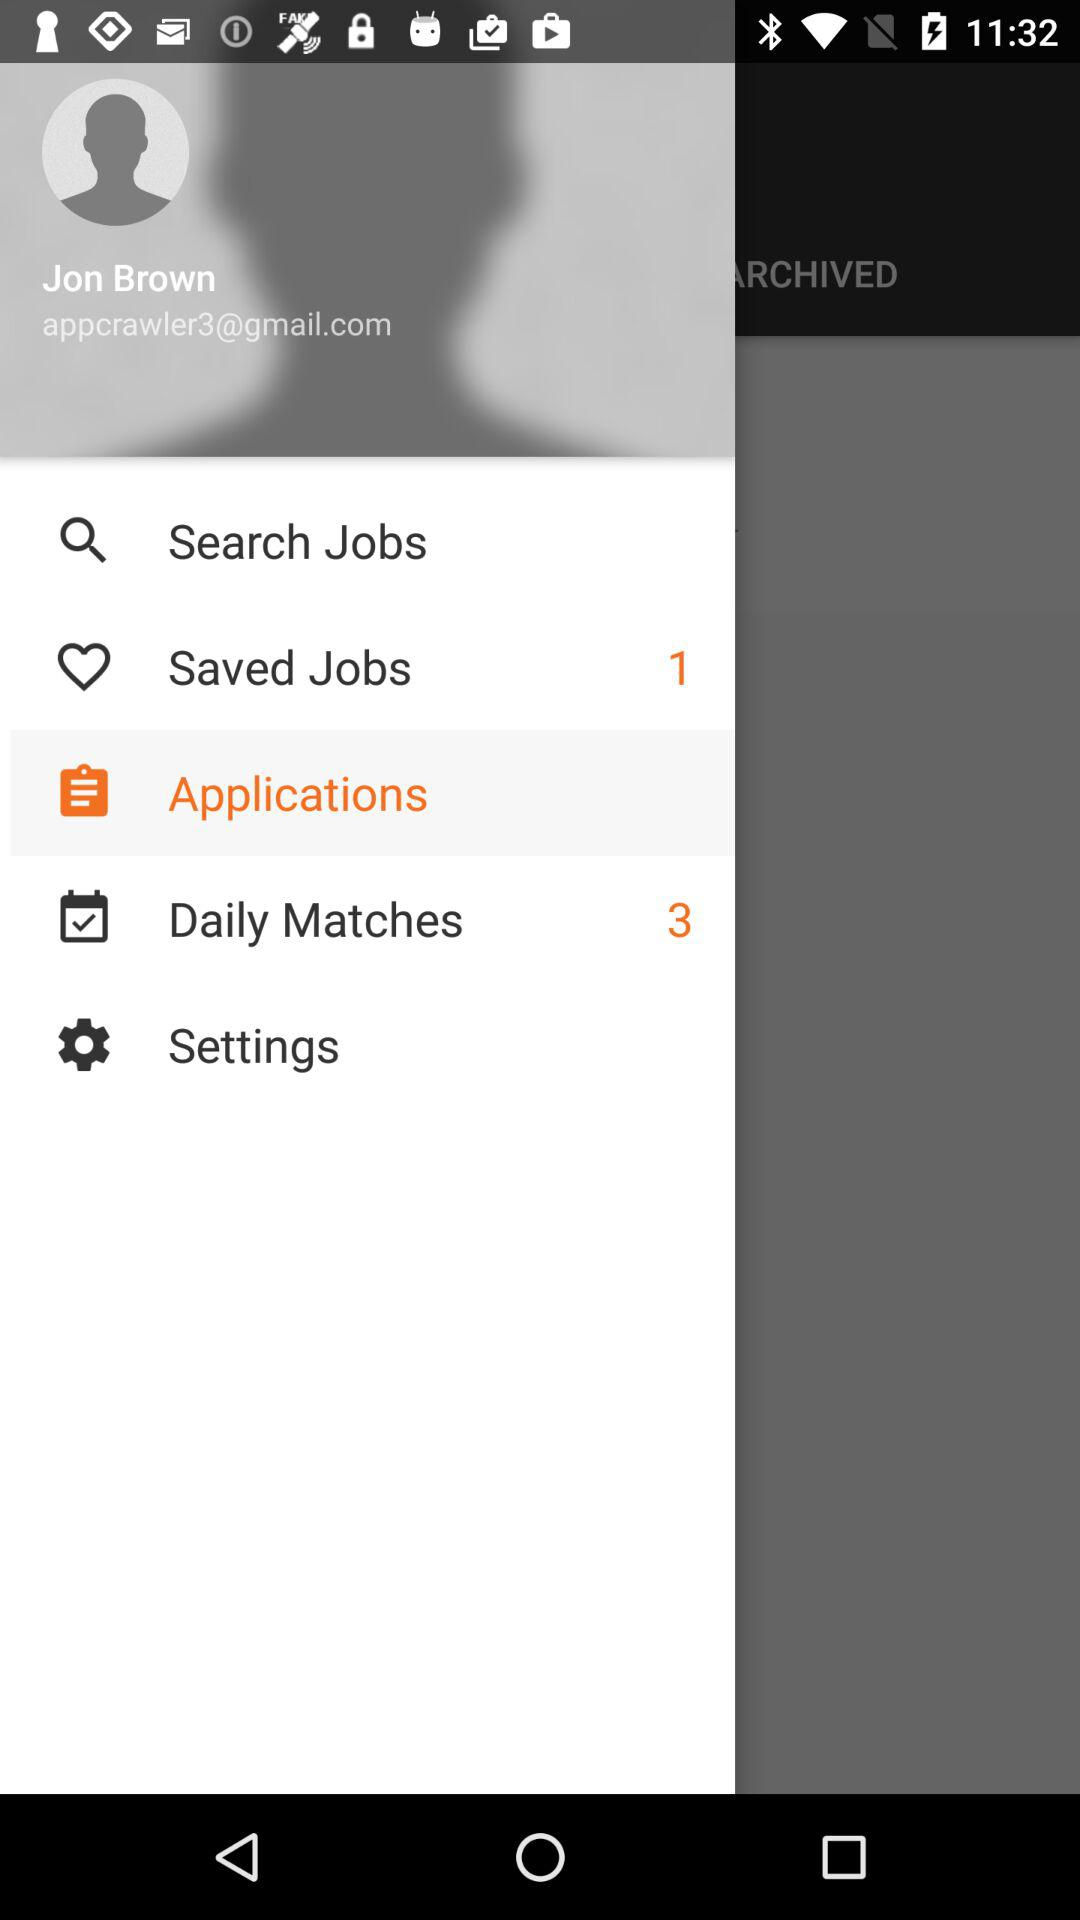What is the email address? The email address is "appcrawler3@gmail.com". 